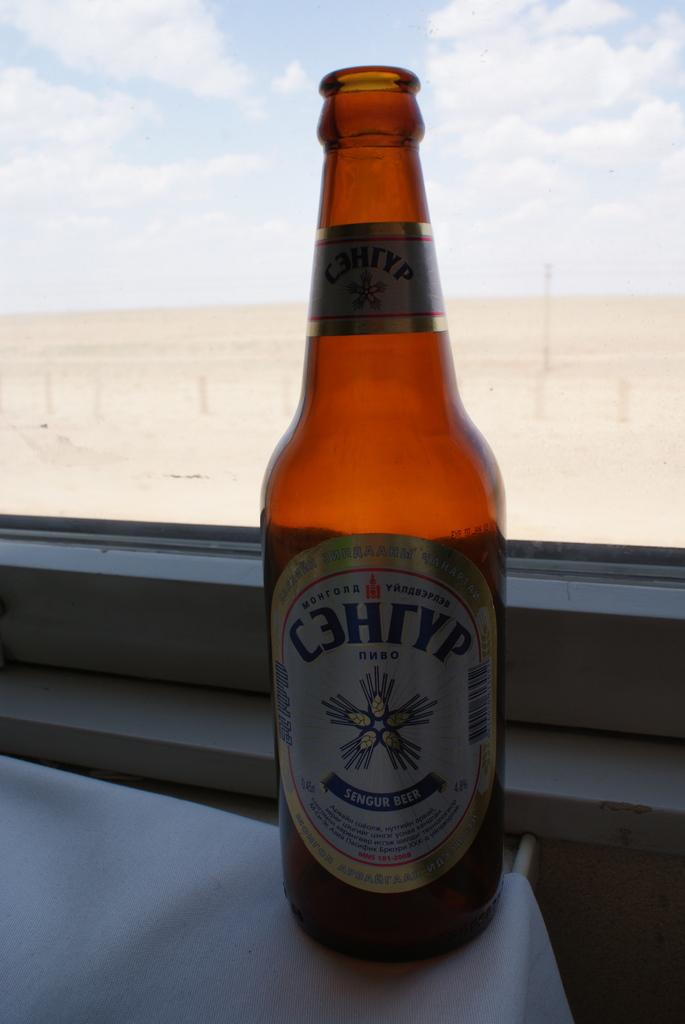<image>
Offer a succinct explanation of the picture presented. a bottle of Sengur Beer with cyrillic writing near a window 